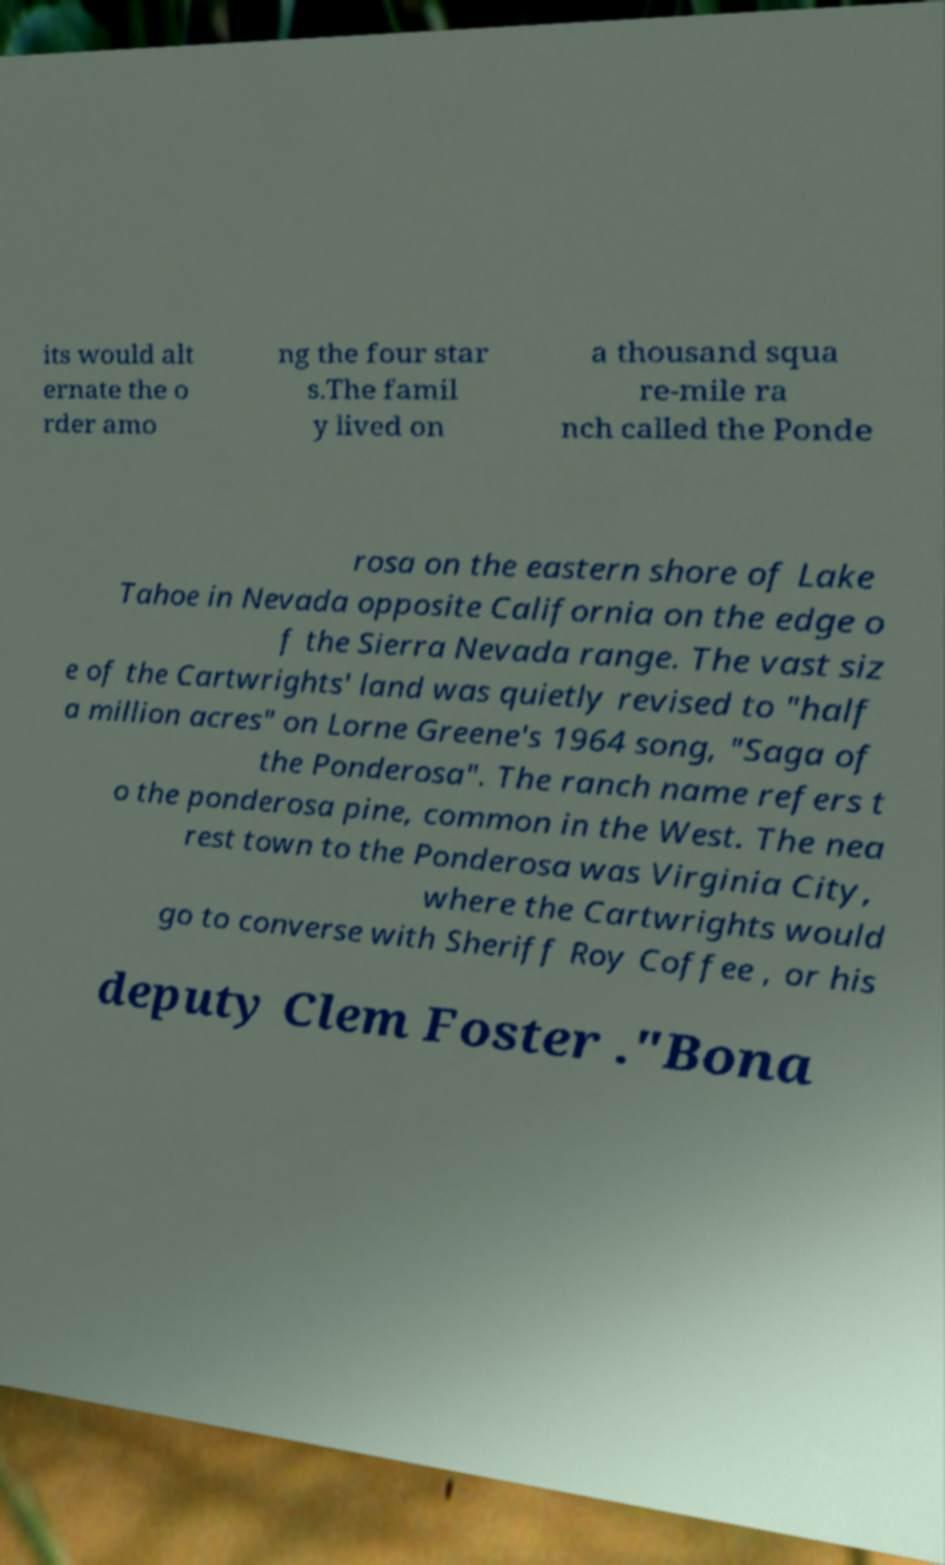Can you read and provide the text displayed in the image?This photo seems to have some interesting text. Can you extract and type it out for me? its would alt ernate the o rder amo ng the four star s.The famil y lived on a thousand squa re-mile ra nch called the Ponde rosa on the eastern shore of Lake Tahoe in Nevada opposite California on the edge o f the Sierra Nevada range. The vast siz e of the Cartwrights' land was quietly revised to "half a million acres" on Lorne Greene's 1964 song, "Saga of the Ponderosa". The ranch name refers t o the ponderosa pine, common in the West. The nea rest town to the Ponderosa was Virginia City, where the Cartwrights would go to converse with Sheriff Roy Coffee , or his deputy Clem Foster ."Bona 